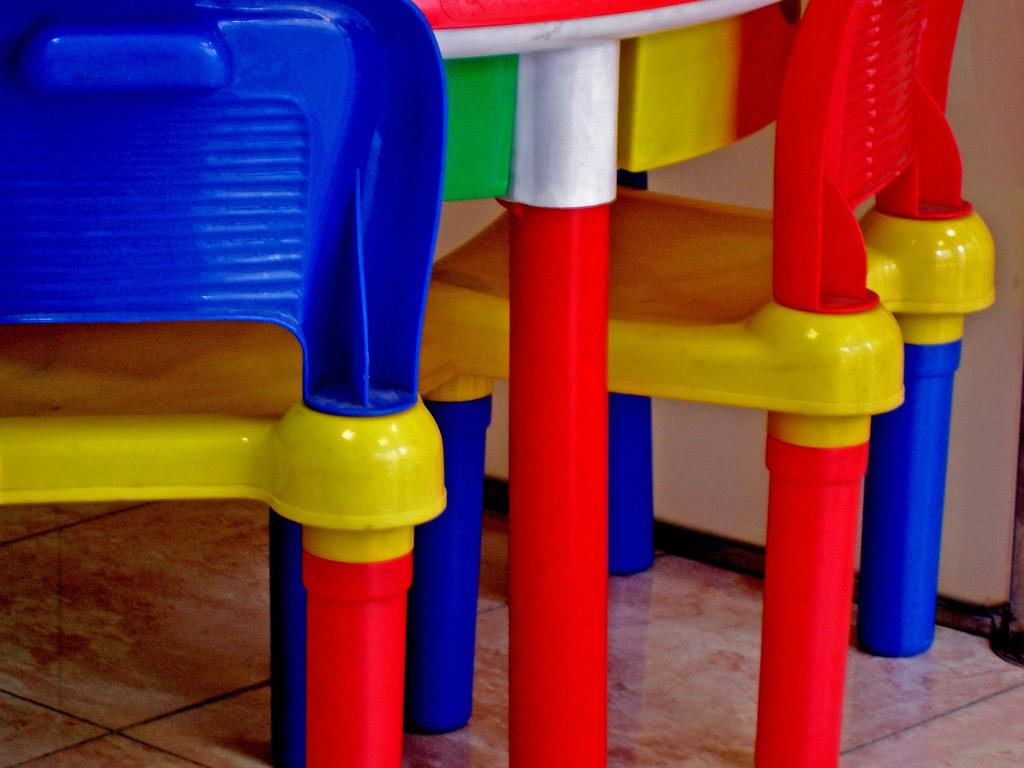How many chairs are in the image? There are two chairs in the image. Where are the chairs located? The chairs are placed on the floor. What can be seen in the center of the image? There is a red table leg in the center of the image. What is visible in the background of the image? The background of the image includes a wall. What type of cracker is on the list that is on the paper in the image? There is no cracker, list, or paper present in the image. 